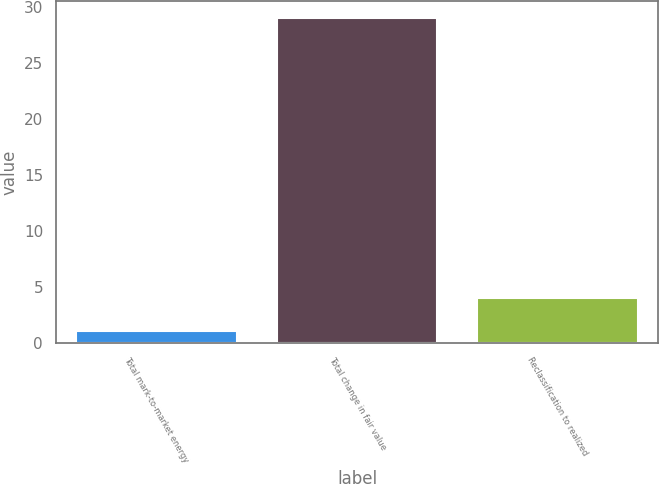<chart> <loc_0><loc_0><loc_500><loc_500><bar_chart><fcel>Total mark-to-market energy<fcel>Total change in fair value<fcel>Reclassification to realized<nl><fcel>1<fcel>29<fcel>4<nl></chart> 